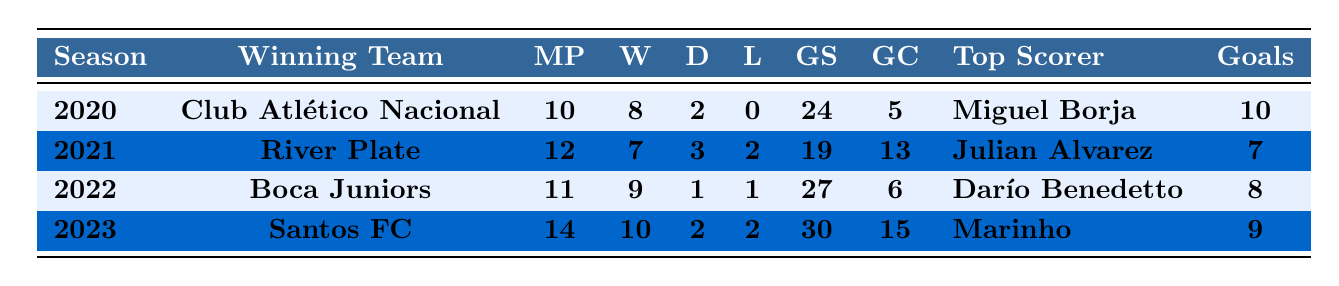What team won the Copa Ramírez in 2022? The table clearly lists the winning team for each season. In 2022, the winning team is Boca Juniors.
Answer: Boca Juniors How many goals did Club Atlético Nacional score in 2020? According to the table, Club Atlético Nacional scored 24 goals in the 2020 season.
Answer: 24 In which season did the winning team have the highest number of wins? By looking at the wins column, Santos FC in 2023 had the highest wins with 10.
Answer: 2023 What is the total number of matches played by the winning teams in 2021 and 2022 combined? The total matches played in 2021 is 12 and in 2022 is 11. Combining them gives 12 + 11 = 23.
Answer: 23 Which team conceded the least goals during their winning season? By examining the goals conceded column, Club Atlético Nacional in 2020 only conceded 5 goals, which is the least.
Answer: Club Atlético Nacional What is the average number of wins for the winning teams over the four seasons? The total wins across all seasons is 8 (2020) + 7 (2021) + 9 (2022) + 10 (2023) = 34. There are 4 teams, so the average is 34 / 4 = 8.5.
Answer: 8.5 Was there a winning team that did not lose any matches? Checking the losses column, Club Atlético Nacional in 2020 had 0 losses, which means they did not lose any matches during that season.
Answer: Yes How many goals were scored by the top scorer of River Plate? The table shows that Julian Alvarez, the top scorer of River Plate in 2021, scored 7 goals.
Answer: 7 Which winning team had a better goal difference in their season, Boca Juniors or Santos FC? Boca Juniors had 27 goals scored and 6 goals conceded, resulting in a goal difference of 21 (27 - 6). Santos FC scored 30 and conceded 15, giving a difference of 15 (30 - 15). Thus, Boca Juniors had the better goal difference.
Answer: Boca Juniors What is the range of matches played by the winning teams over the four seasons? The highest matches played is 14 (Santos FC in 2023) and the lowest is 10 (Club Atlético Nacional in 2020). The range is 14 - 10 = 4.
Answer: 4 